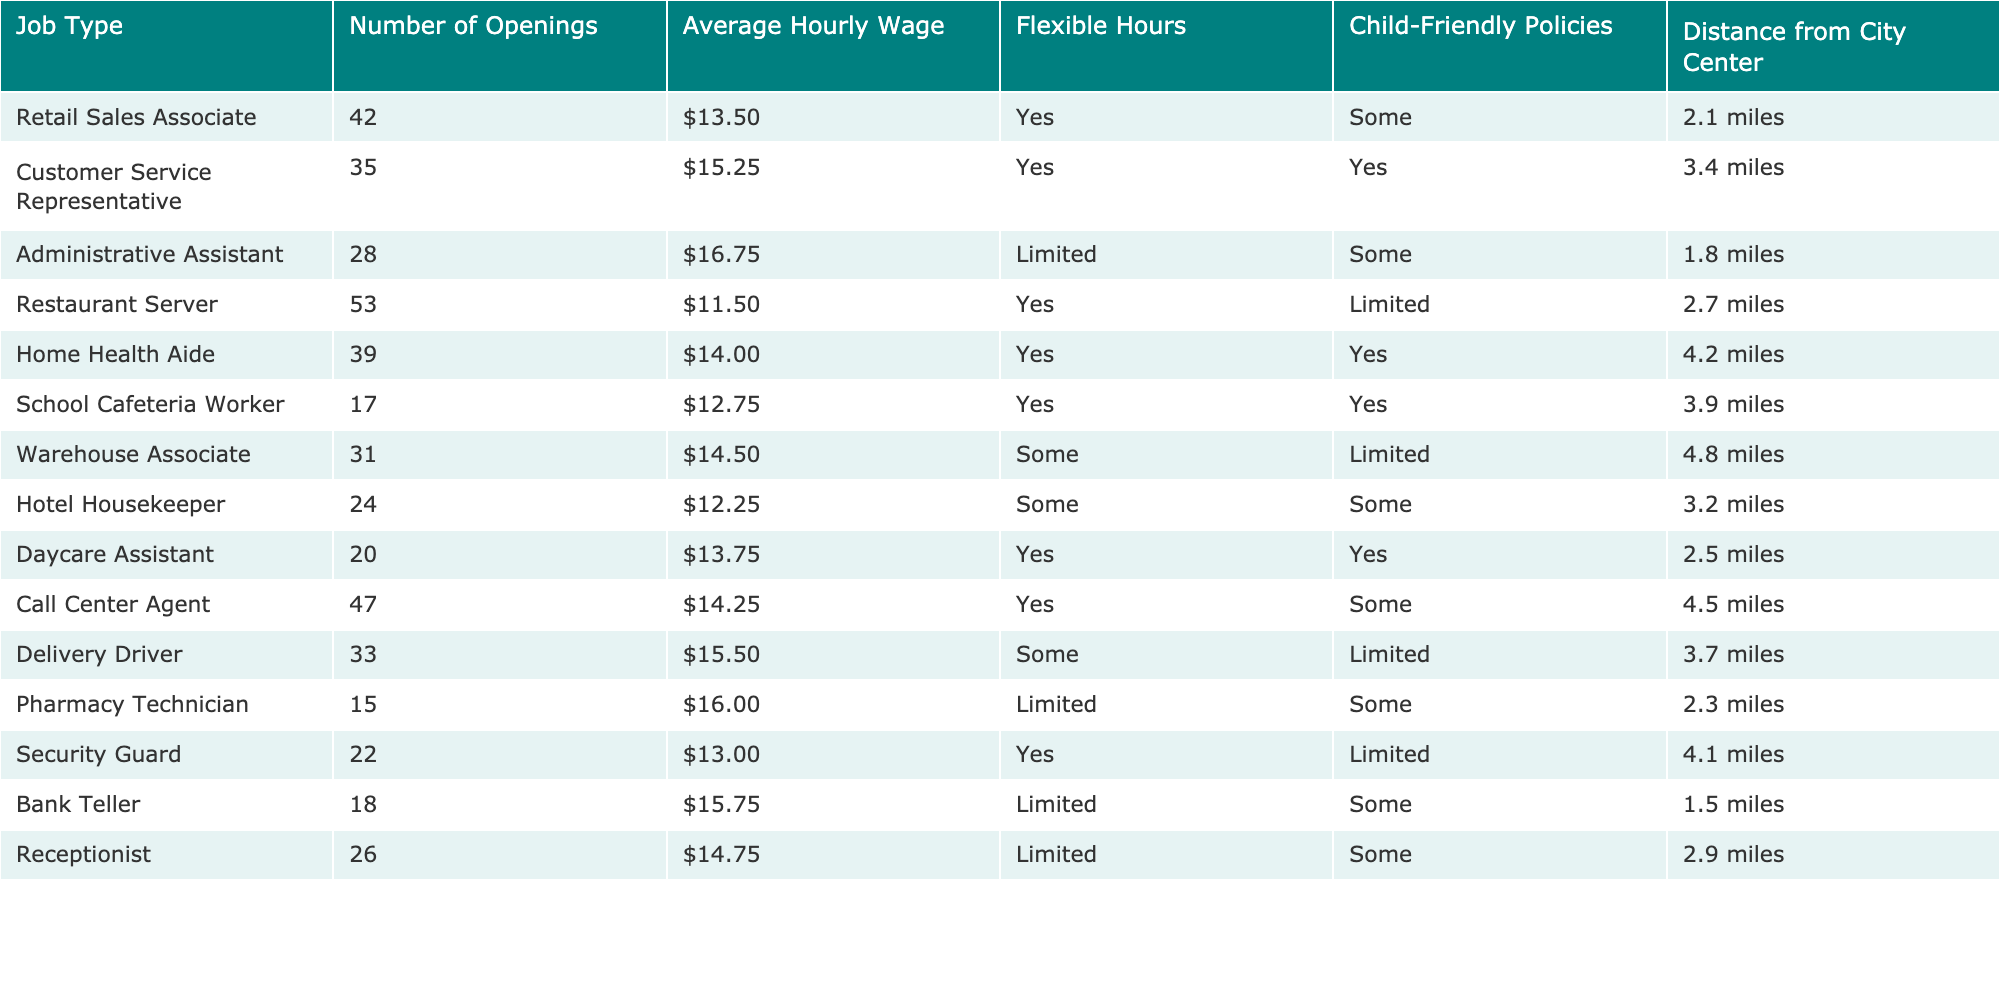What is the job type with the highest number of openings? The table shows the number of openings for each job type. Comparing the numbers, the job type with the highest openings is Restaurant Server with 53 openings.
Answer: Restaurant Server How many job types offer flexible hours? By examining the table, I can count the job types that have "Yes" indicated under the Flexible Hours column. There are 7 job types that offer flexible hours.
Answer: 7 What is the average hourly wage of all job types? To find the average, I sum all the hourly wages: (13.50 + 15.25 + 16.75 + 11.50 + 14.00 + 12.75 + 14.50 + 12.25 + 13.75 + 14.25 + 15.50 + 16.00 + 13.00 + 15.75 + 14.75) = 209.25. There are 15 job types, so the average is 209.25 / 15 = 13.95.
Answer: $13.95 Is there a job type that has both flexible hours and child-friendly policies? The table shows the Flexible Hours and Child-Friendly Policies columns. Checking the job types, Customer Service Representative, Home Health Aide, School Cafeteria Worker, Daycare Assistant, and Call Center Agent have both attributes.
Answer: Yes What is the distance of the farthest job type from the city center? The Distance from City Center column shows the distances for each job type. The maximum distance value is 4.8 miles for the Warehouse Associate.
Answer: 4.8 miles How many job openings are there in total for retail and customer service-related positions? Summing the openings for Retail Sales Associate (42) and Customer Service Representative (35) gives a total of 42 + 35 = 77 job openings in these categories.
Answer: 77 Which job type has the highest average hourly wage among those that offer limited flexibility? The job types that offer Limited under Flexible Hours are Administrative Assistant, Pharmacy Technician, Bank Teller, Receptionist, Warehouse Associate, and Security Guard. Their average hourly wages are: 16.75, 16.00, 15.75, 14.75, 14.50, and 13.00. The highest wage among them is 16.75 for Administrative Assistant.
Answer: Administrative Assistant What percentage of jobs listed have child-friendly policies? There are 15 job types in total. Counting those with "Yes" in the Child-Friendly Policies column, we have 7. To find the percentage, I calculate (7/15) * 100 = 46.67%.
Answer: 46.67% How does the average hourly wage of jobs with flexible hours compare to those without? First, I calculate the average wage for jobs with flexible hours (13.50 + 15.25 + 11.50 + 14.00 + 12.75 + 13.75 + 14.25 = 95.00), which has 7 jobs, resulting in an average of 95 / 7 = 13.57. For jobs without flexible hours (16.75 + 12.25 + 15.75 + 14.50 + 13.00 = 72.25), which has 5 jobs, giving an average of 72.25 / 5 = 14.45. Thus, the average wage for jobs without flexible hours is higher than for those with.
Answer: Jobs without flexible hours have a higher average wage 